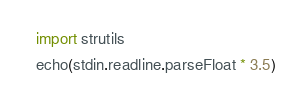<code> <loc_0><loc_0><loc_500><loc_500><_Nim_>import strutils
echo(stdin.readline.parseFloat * 3.5)
</code> 